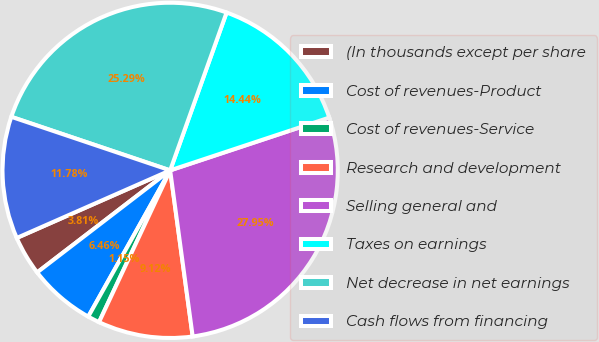<chart> <loc_0><loc_0><loc_500><loc_500><pie_chart><fcel>(In thousands except per share<fcel>Cost of revenues-Product<fcel>Cost of revenues-Service<fcel>Research and development<fcel>Selling general and<fcel>Taxes on earnings<fcel>Net decrease in net earnings<fcel>Cash flows from financing<nl><fcel>3.81%<fcel>6.46%<fcel>1.15%<fcel>9.12%<fcel>27.95%<fcel>14.44%<fcel>25.29%<fcel>11.78%<nl></chart> 